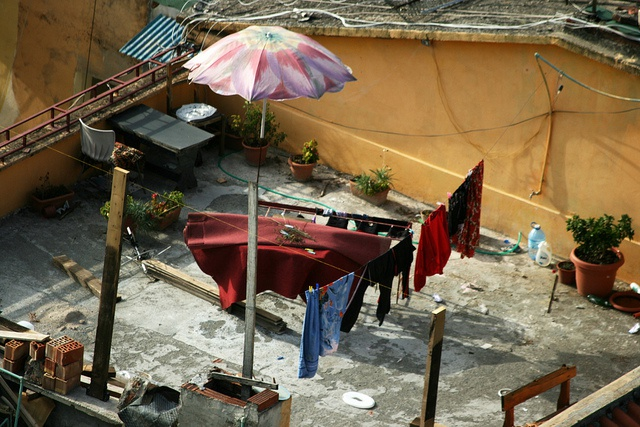Describe the objects in this image and their specific colors. I can see umbrella in darkgreen, lightgray, darkgray, lightpink, and gray tones, potted plant in darkgreen, black, maroon, brown, and olive tones, dining table in darkgreen, black, gray, and purple tones, chair in darkgreen, black, gray, and maroon tones, and potted plant in darkgreen, black, and maroon tones in this image. 